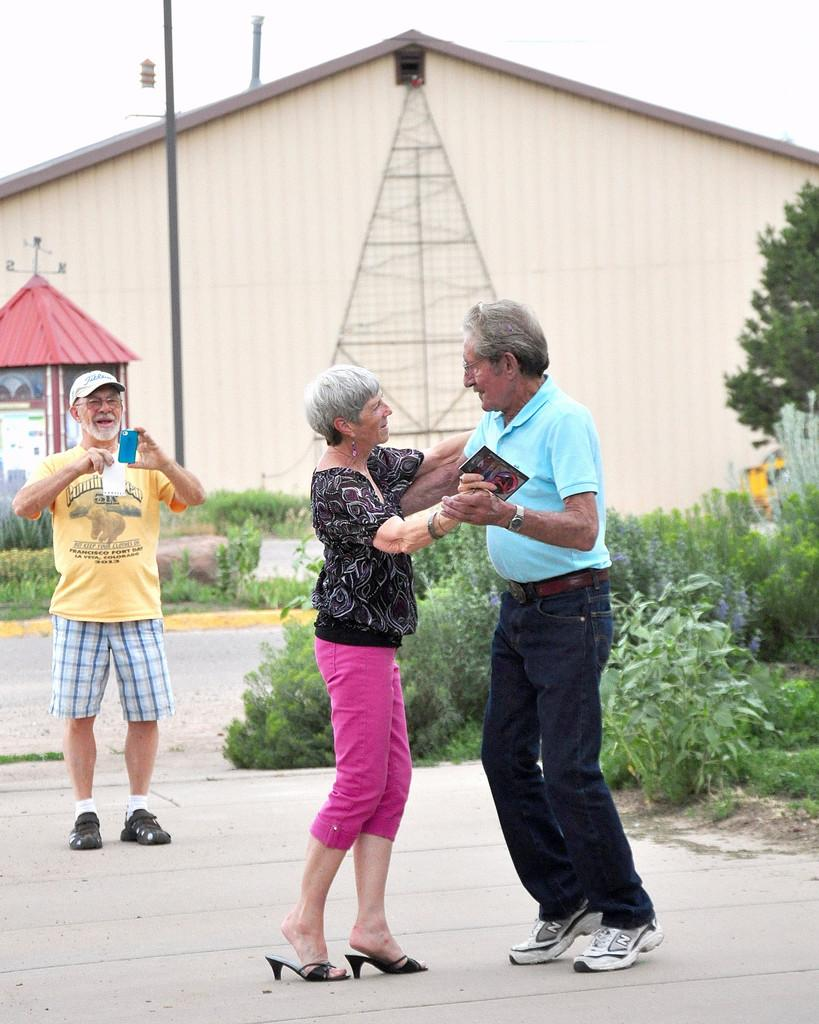How many people are in the image? There are three people in the image. What is one of the people doing? One of the people is holding a mobile phone. What is the person with the mobile phone doing? The person with the mobile phone is capturing a photo. Can you describe the setting in the image? There is a house, poles, plants, trees, and a booth in the image. What is visible in the background of the image? The sky is visible in the image. What type of berry can be seen growing on the trees in the image? There are no berries visible on the trees in the image; only plants and trees are present. What type of stone is used to build the booth in the image? There is no information about the material used to build the booth in the image. 